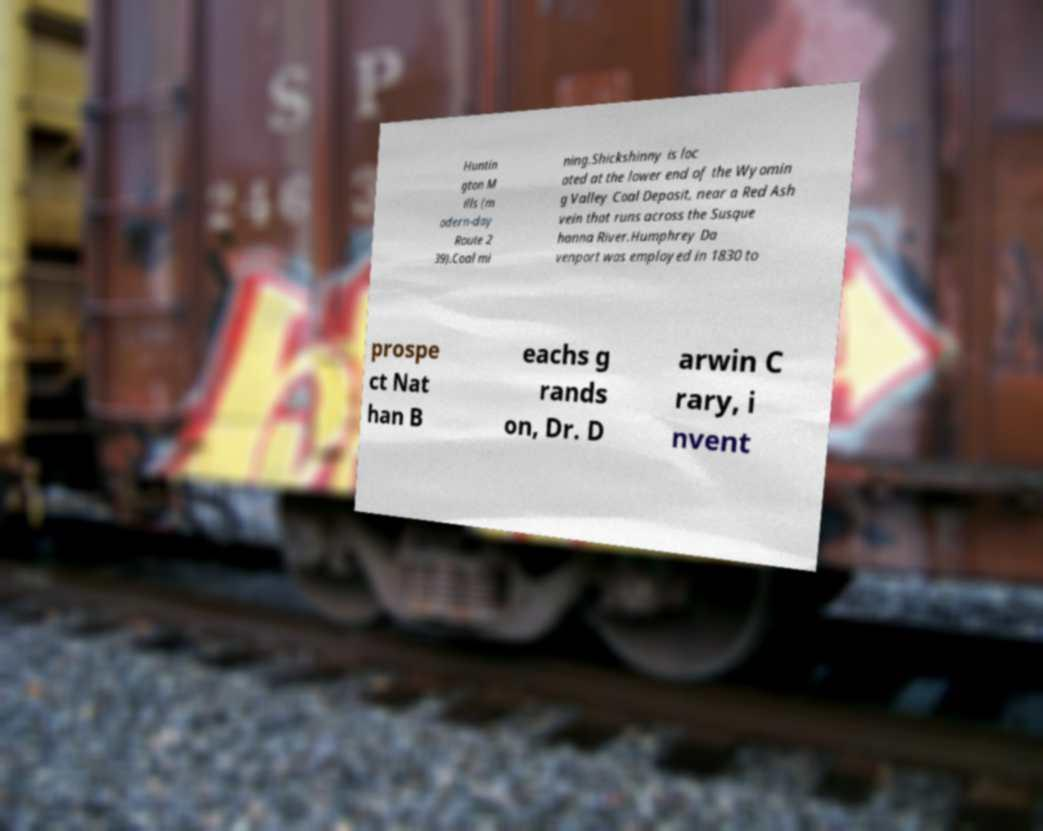For documentation purposes, I need the text within this image transcribed. Could you provide that? Huntin gton M ills (m odern-day Route 2 39).Coal mi ning.Shickshinny is loc ated at the lower end of the Wyomin g Valley Coal Deposit, near a Red Ash vein that runs across the Susque hanna River.Humphrey Da venport was employed in 1830 to prospe ct Nat han B eachs g rands on, Dr. D arwin C rary, i nvent 